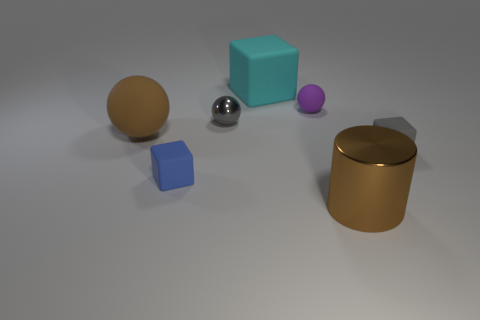There is a gray matte object; is it the same shape as the metal thing behind the large ball?
Provide a succinct answer. No. Is the number of brown balls greater than the number of green objects?
Your answer should be very brief. Yes. Are there any other things that are the same color as the cylinder?
Your answer should be very brief. Yes. The large cyan thing that is the same material as the purple object is what shape?
Provide a succinct answer. Cube. What material is the gray object to the left of the tiny gray object that is on the right side of the small gray ball?
Your answer should be compact. Metal. There is a gray thing that is behind the brown matte sphere; does it have the same shape as the large brown metallic thing?
Keep it short and to the point. No. Are there more big blocks on the right side of the large shiny object than green matte cylinders?
Make the answer very short. No. What shape is the matte thing that is the same color as the cylinder?
Give a very brief answer. Sphere. What number of cubes are either gray rubber things or small blue things?
Your answer should be compact. 2. The tiny thing right of the large brown object that is on the right side of the tiny purple object is what color?
Your answer should be compact. Gray. 